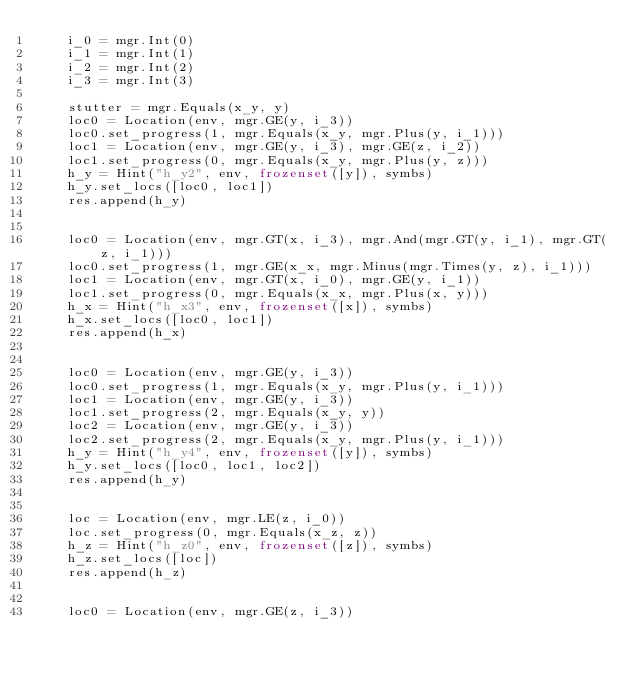Convert code to text. <code><loc_0><loc_0><loc_500><loc_500><_Python_>    i_0 = mgr.Int(0)
    i_1 = mgr.Int(1)
    i_2 = mgr.Int(2)
    i_3 = mgr.Int(3)

    stutter = mgr.Equals(x_y, y)
    loc0 = Location(env, mgr.GE(y, i_3))
    loc0.set_progress(1, mgr.Equals(x_y, mgr.Plus(y, i_1)))
    loc1 = Location(env, mgr.GE(y, i_3), mgr.GE(z, i_2))
    loc1.set_progress(0, mgr.Equals(x_y, mgr.Plus(y, z)))
    h_y = Hint("h_y2", env, frozenset([y]), symbs)
    h_y.set_locs([loc0, loc1])
    res.append(h_y)


    loc0 = Location(env, mgr.GT(x, i_3), mgr.And(mgr.GT(y, i_1), mgr.GT(z, i_1)))
    loc0.set_progress(1, mgr.GE(x_x, mgr.Minus(mgr.Times(y, z), i_1)))
    loc1 = Location(env, mgr.GT(x, i_0), mgr.GE(y, i_1))
    loc1.set_progress(0, mgr.Equals(x_x, mgr.Plus(x, y)))
    h_x = Hint("h_x3", env, frozenset([x]), symbs)
    h_x.set_locs([loc0, loc1])
    res.append(h_x)


    loc0 = Location(env, mgr.GE(y, i_3))
    loc0.set_progress(1, mgr.Equals(x_y, mgr.Plus(y, i_1)))
    loc1 = Location(env, mgr.GE(y, i_3))
    loc1.set_progress(2, mgr.Equals(x_y, y))
    loc2 = Location(env, mgr.GE(y, i_3))
    loc2.set_progress(2, mgr.Equals(x_y, mgr.Plus(y, i_1)))
    h_y = Hint("h_y4", env, frozenset([y]), symbs)
    h_y.set_locs([loc0, loc1, loc2])
    res.append(h_y)


    loc = Location(env, mgr.LE(z, i_0))
    loc.set_progress(0, mgr.Equals(x_z, z))
    h_z = Hint("h_z0", env, frozenset([z]), symbs)
    h_z.set_locs([loc])
    res.append(h_z)


    loc0 = Location(env, mgr.GE(z, i_3))</code> 